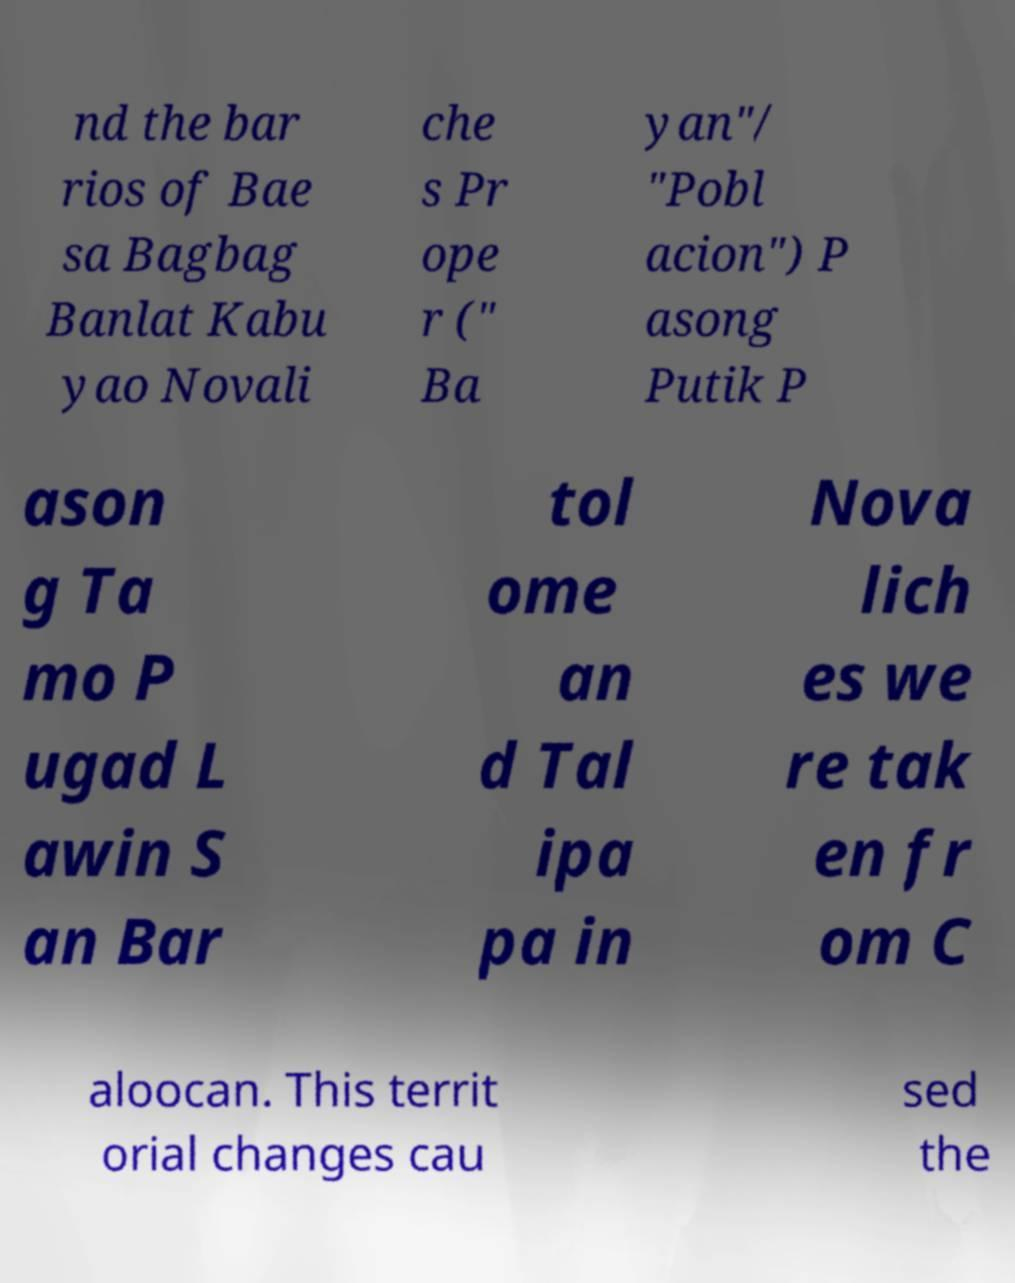There's text embedded in this image that I need extracted. Can you transcribe it verbatim? nd the bar rios of Bae sa Bagbag Banlat Kabu yao Novali che s Pr ope r (" Ba yan"/ "Pobl acion") P asong Putik P ason g Ta mo P ugad L awin S an Bar tol ome an d Tal ipa pa in Nova lich es we re tak en fr om C aloocan. This territ orial changes cau sed the 